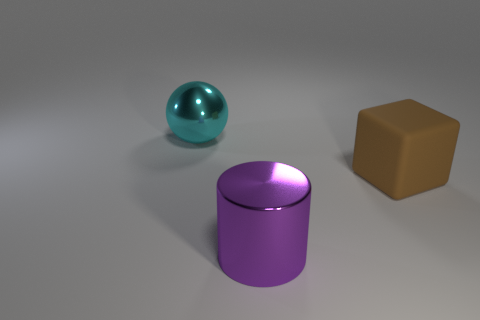Add 1 purple objects. How many objects exist? 4 Subtract 1 brown blocks. How many objects are left? 2 Subtract all cubes. How many objects are left? 2 Subtract 1 cylinders. How many cylinders are left? 0 Subtract all brown spheres. Subtract all brown cylinders. How many spheres are left? 1 Subtract all cyan balls. How many gray cubes are left? 0 Subtract all big cyan shiny objects. Subtract all cyan metal cubes. How many objects are left? 2 Add 2 big purple metal cylinders. How many big purple metal cylinders are left? 3 Add 3 big cyan rubber objects. How many big cyan rubber objects exist? 3 